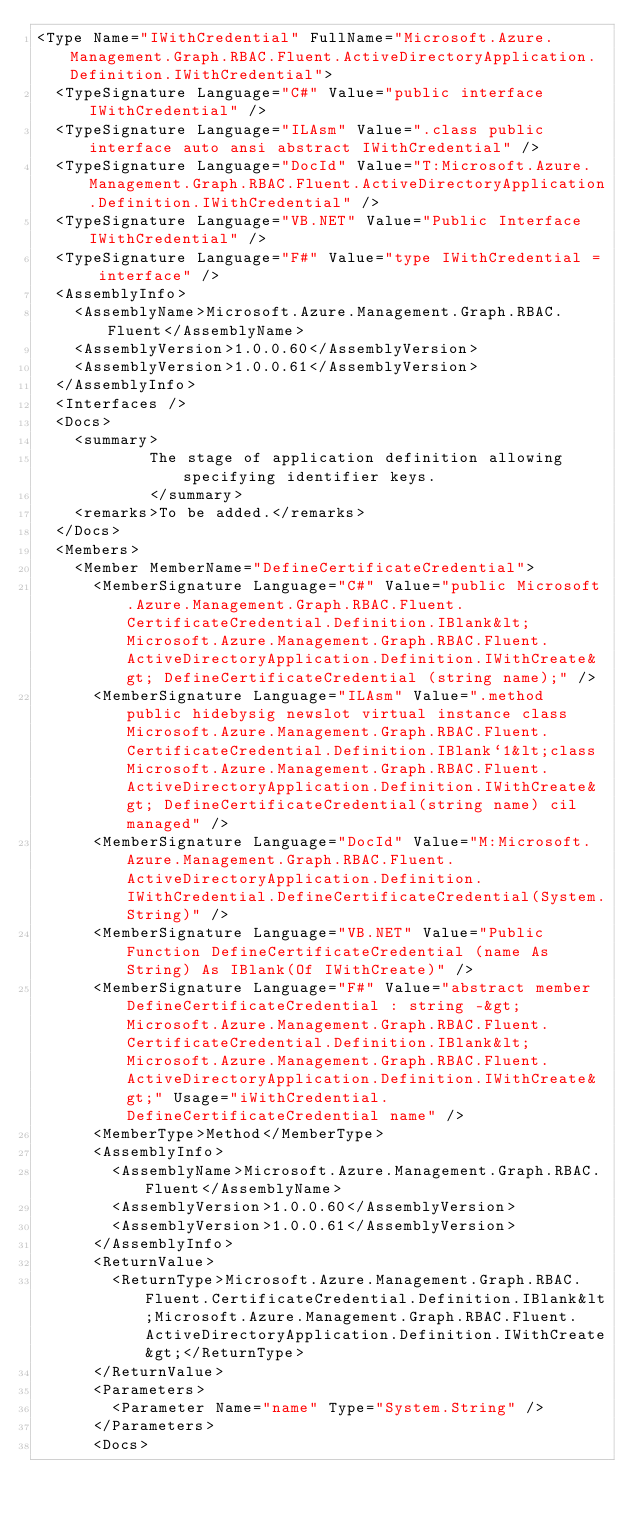<code> <loc_0><loc_0><loc_500><loc_500><_XML_><Type Name="IWithCredential" FullName="Microsoft.Azure.Management.Graph.RBAC.Fluent.ActiveDirectoryApplication.Definition.IWithCredential">
  <TypeSignature Language="C#" Value="public interface IWithCredential" />
  <TypeSignature Language="ILAsm" Value=".class public interface auto ansi abstract IWithCredential" />
  <TypeSignature Language="DocId" Value="T:Microsoft.Azure.Management.Graph.RBAC.Fluent.ActiveDirectoryApplication.Definition.IWithCredential" />
  <TypeSignature Language="VB.NET" Value="Public Interface IWithCredential" />
  <TypeSignature Language="F#" Value="type IWithCredential = interface" />
  <AssemblyInfo>
    <AssemblyName>Microsoft.Azure.Management.Graph.RBAC.Fluent</AssemblyName>
    <AssemblyVersion>1.0.0.60</AssemblyVersion>
    <AssemblyVersion>1.0.0.61</AssemblyVersion>
  </AssemblyInfo>
  <Interfaces />
  <Docs>
    <summary>
            The stage of application definition allowing specifying identifier keys.
            </summary>
    <remarks>To be added.</remarks>
  </Docs>
  <Members>
    <Member MemberName="DefineCertificateCredential">
      <MemberSignature Language="C#" Value="public Microsoft.Azure.Management.Graph.RBAC.Fluent.CertificateCredential.Definition.IBlank&lt;Microsoft.Azure.Management.Graph.RBAC.Fluent.ActiveDirectoryApplication.Definition.IWithCreate&gt; DefineCertificateCredential (string name);" />
      <MemberSignature Language="ILAsm" Value=".method public hidebysig newslot virtual instance class Microsoft.Azure.Management.Graph.RBAC.Fluent.CertificateCredential.Definition.IBlank`1&lt;class Microsoft.Azure.Management.Graph.RBAC.Fluent.ActiveDirectoryApplication.Definition.IWithCreate&gt; DefineCertificateCredential(string name) cil managed" />
      <MemberSignature Language="DocId" Value="M:Microsoft.Azure.Management.Graph.RBAC.Fluent.ActiveDirectoryApplication.Definition.IWithCredential.DefineCertificateCredential(System.String)" />
      <MemberSignature Language="VB.NET" Value="Public Function DefineCertificateCredential (name As String) As IBlank(Of IWithCreate)" />
      <MemberSignature Language="F#" Value="abstract member DefineCertificateCredential : string -&gt; Microsoft.Azure.Management.Graph.RBAC.Fluent.CertificateCredential.Definition.IBlank&lt;Microsoft.Azure.Management.Graph.RBAC.Fluent.ActiveDirectoryApplication.Definition.IWithCreate&gt;" Usage="iWithCredential.DefineCertificateCredential name" />
      <MemberType>Method</MemberType>
      <AssemblyInfo>
        <AssemblyName>Microsoft.Azure.Management.Graph.RBAC.Fluent</AssemblyName>
        <AssemblyVersion>1.0.0.60</AssemblyVersion>
        <AssemblyVersion>1.0.0.61</AssemblyVersion>
      </AssemblyInfo>
      <ReturnValue>
        <ReturnType>Microsoft.Azure.Management.Graph.RBAC.Fluent.CertificateCredential.Definition.IBlank&lt;Microsoft.Azure.Management.Graph.RBAC.Fluent.ActiveDirectoryApplication.Definition.IWithCreate&gt;</ReturnType>
      </ReturnValue>
      <Parameters>
        <Parameter Name="name" Type="System.String" />
      </Parameters>
      <Docs></code> 